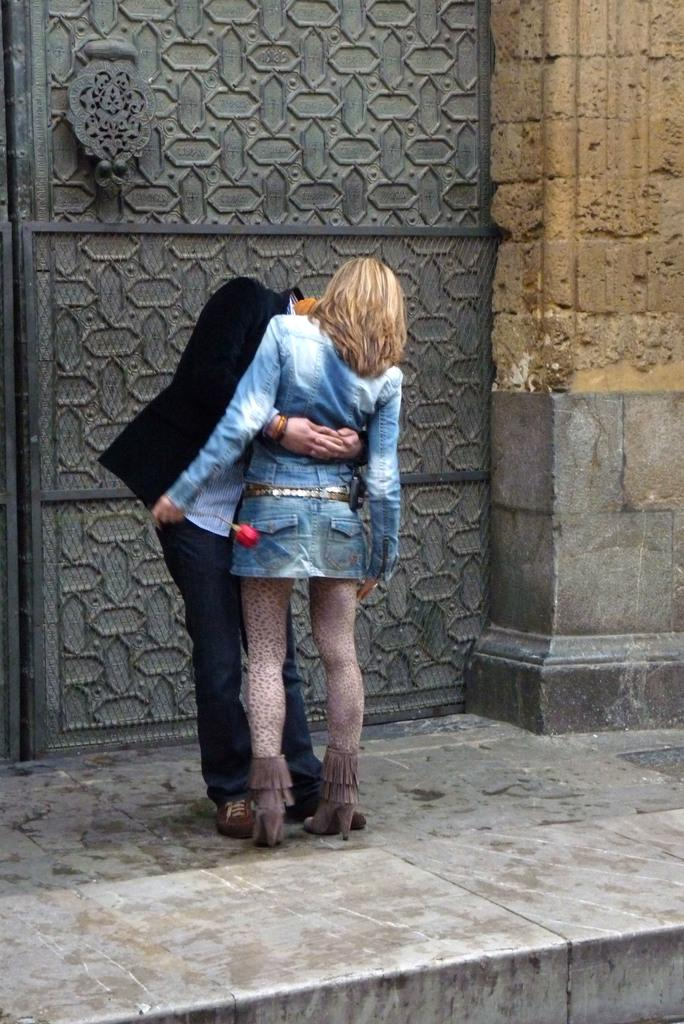What is happening in the image? There are people standing in the image. What can be seen in the background of the image? There is an iron door in the background of the image. Can you describe the woman in the image? A woman is holding a rose flower in her hand. Where are the books located in the image? There are no books present in the image. 